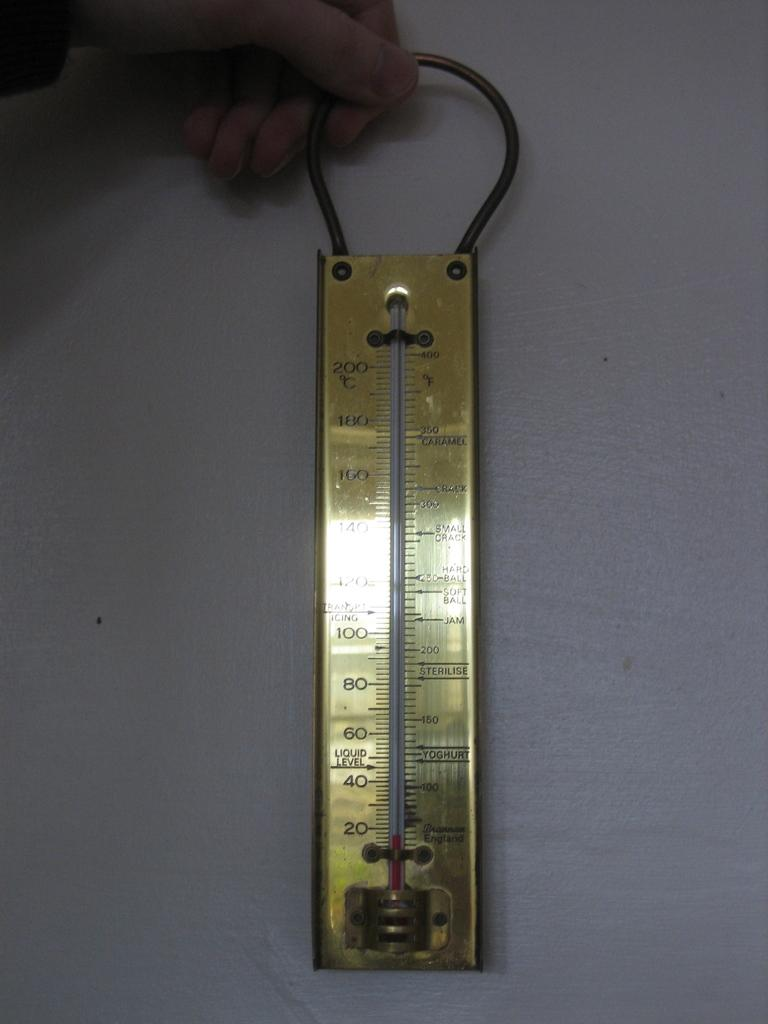<image>
Write a terse but informative summary of the picture. A gold thermometer has yoghurt on the right lower side and sterilise above it. 